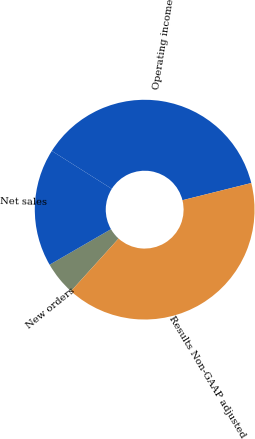Convert chart to OTSL. <chart><loc_0><loc_0><loc_500><loc_500><pie_chart><fcel>New orders<fcel>Net sales<fcel>Operating income<fcel>Results Non-GAAP adjusted<nl><fcel>4.95%<fcel>17.33%<fcel>37.13%<fcel>40.59%<nl></chart> 